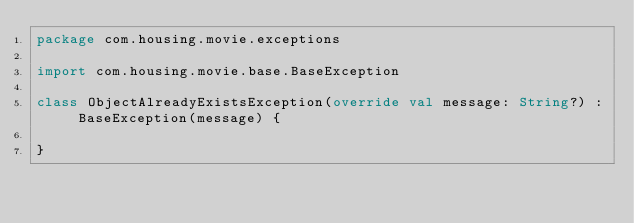Convert code to text. <code><loc_0><loc_0><loc_500><loc_500><_Kotlin_>package com.housing.movie.exceptions

import com.housing.movie.base.BaseException

class ObjectAlreadyExistsException(override val message: String?) : BaseException(message) {

}</code> 